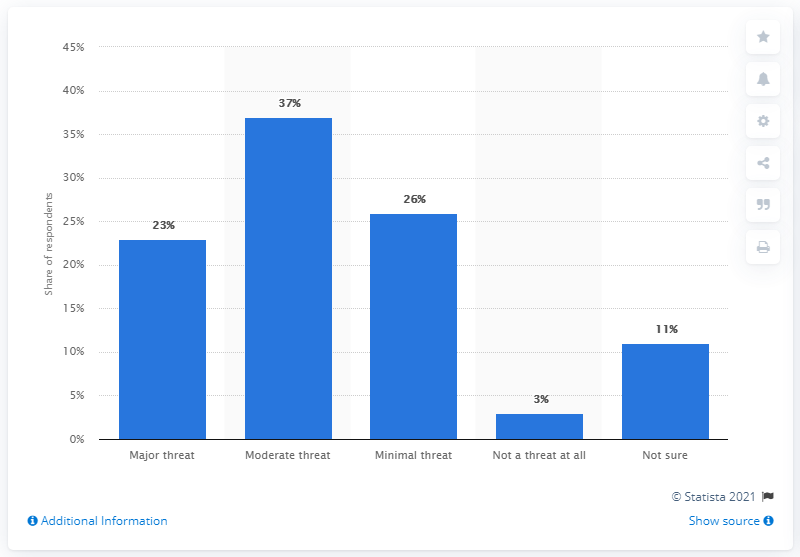Mention a couple of crucial points in this snapshot. The results of the survey indicate that 23% of respondents believe that the novel Coronavirus represents a major threat to public health. 